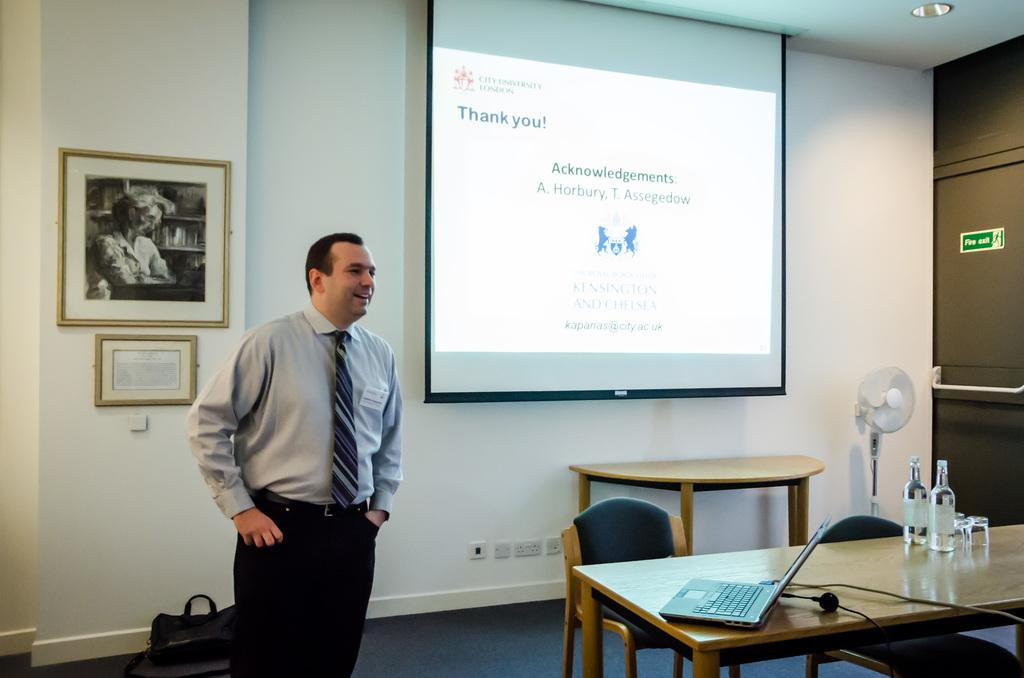What is the main subject in the image? There is a man standing in the image. What is located near the man? There is a table in the image. What is on the table? There is a laptop and wine bottles on the table. What is at the back of the image? There is a projector screen at the back of the image. What month is depicted on the ring in the image? There is no ring present in the image, so it is not possible to determine the month depicted on it. 